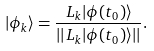<formula> <loc_0><loc_0><loc_500><loc_500>| \phi _ { k } \rangle = \frac { L _ { k } | \phi ( t _ { 0 } ) \rangle } { | | L _ { k } | \phi ( t _ { 0 } ) \rangle | | } .</formula> 